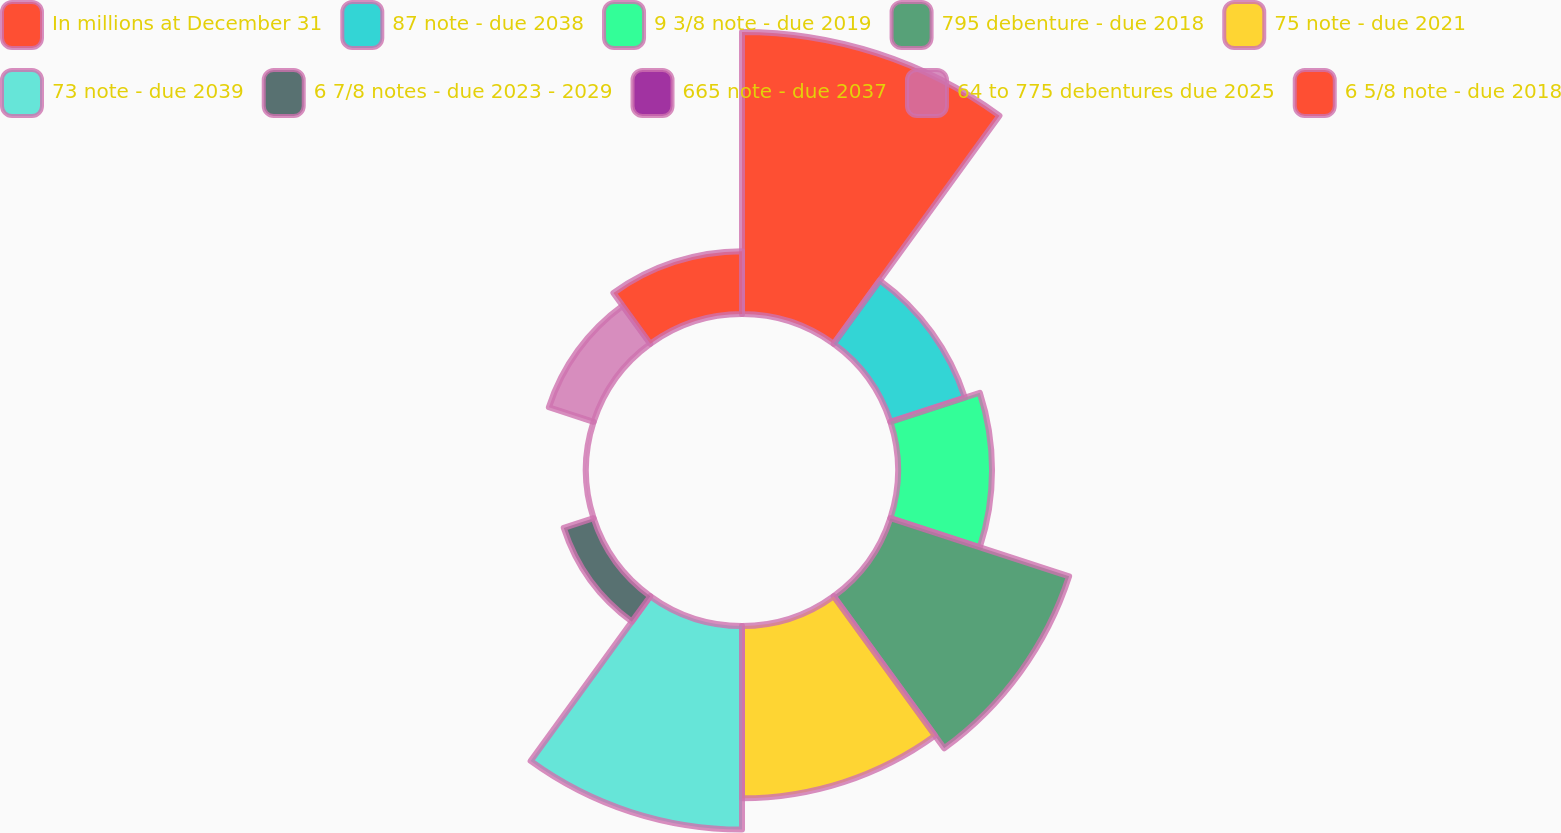Convert chart to OTSL. <chart><loc_0><loc_0><loc_500><loc_500><pie_chart><fcel>In millions at December 31<fcel>87 note - due 2038<fcel>9 3/8 note - due 2019<fcel>795 debenture - due 2018<fcel>75 note - due 2021<fcel>73 note - due 2039<fcel>6 7/8 notes - due 2023 - 2029<fcel>665 note - due 2037<fcel>64 to 775 debentures due 2025<fcel>6 5/8 note - due 2018<nl><fcel>24.32%<fcel>6.76%<fcel>8.11%<fcel>16.21%<fcel>14.86%<fcel>17.56%<fcel>2.71%<fcel>0.01%<fcel>4.06%<fcel>5.41%<nl></chart> 